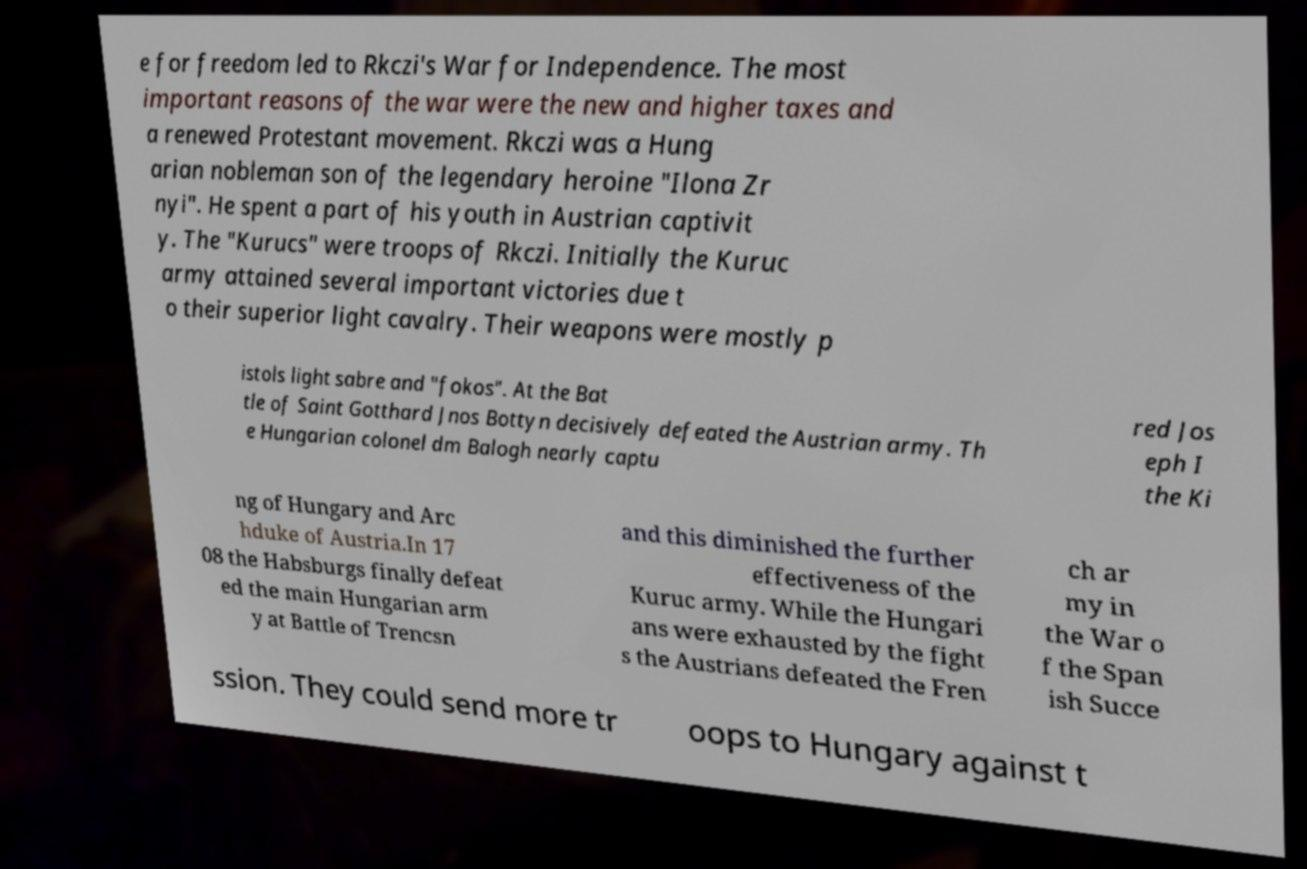For documentation purposes, I need the text within this image transcribed. Could you provide that? e for freedom led to Rkczi's War for Independence. The most important reasons of the war were the new and higher taxes and a renewed Protestant movement. Rkczi was a Hung arian nobleman son of the legendary heroine "Ilona Zr nyi". He spent a part of his youth in Austrian captivit y. The "Kurucs" were troops of Rkczi. Initially the Kuruc army attained several important victories due t o their superior light cavalry. Their weapons were mostly p istols light sabre and "fokos". At the Bat tle of Saint Gotthard Jnos Bottyn decisively defeated the Austrian army. Th e Hungarian colonel dm Balogh nearly captu red Jos eph I the Ki ng of Hungary and Arc hduke of Austria.In 17 08 the Habsburgs finally defeat ed the main Hungarian arm y at Battle of Trencsn and this diminished the further effectiveness of the Kuruc army. While the Hungari ans were exhausted by the fight s the Austrians defeated the Fren ch ar my in the War o f the Span ish Succe ssion. They could send more tr oops to Hungary against t 